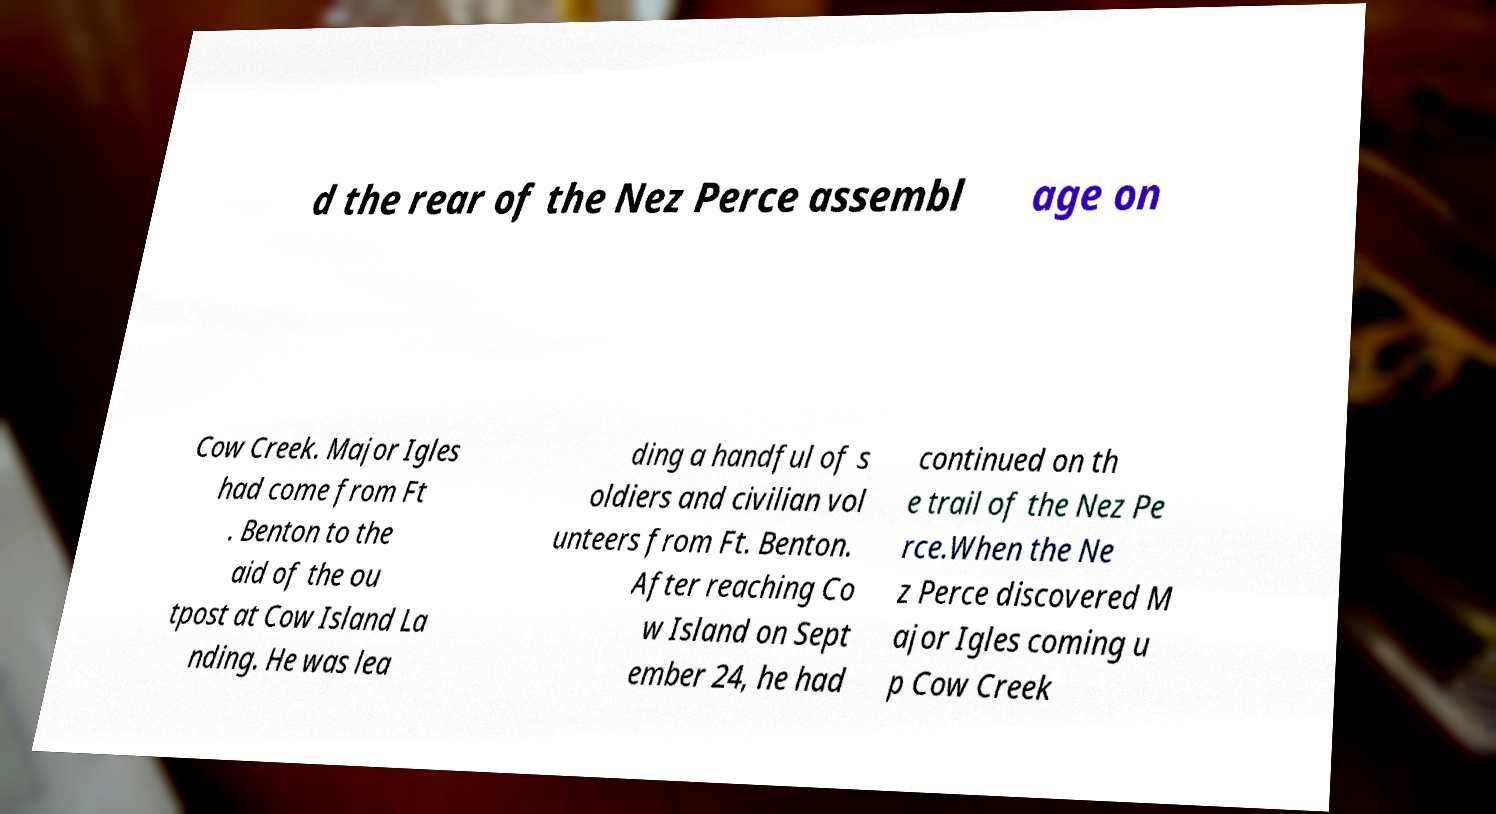Please read and relay the text visible in this image. What does it say? d the rear of the Nez Perce assembl age on Cow Creek. Major Igles had come from Ft . Benton to the aid of the ou tpost at Cow Island La nding. He was lea ding a handful of s oldiers and civilian vol unteers from Ft. Benton. After reaching Co w Island on Sept ember 24, he had continued on th e trail of the Nez Pe rce.When the Ne z Perce discovered M ajor Igles coming u p Cow Creek 